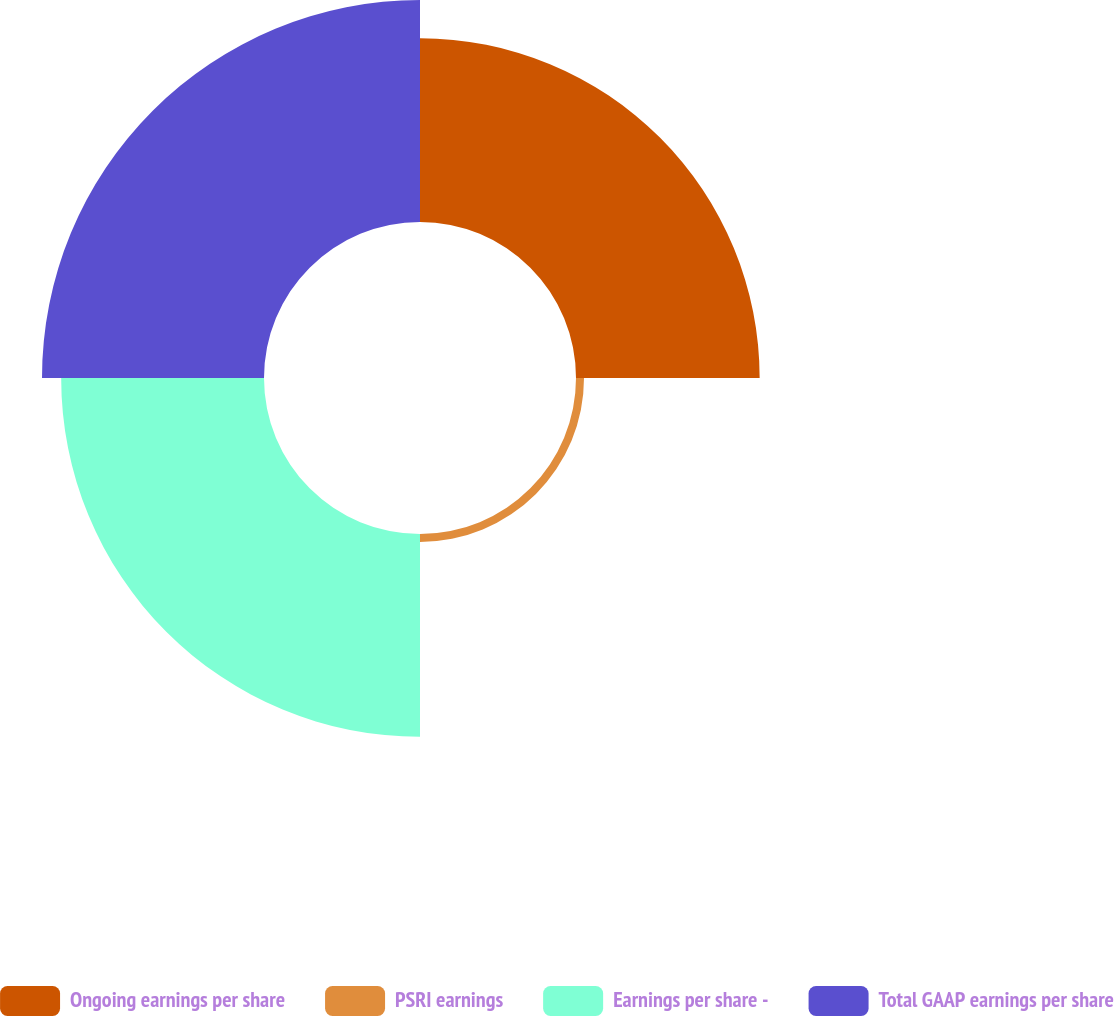Convert chart to OTSL. <chart><loc_0><loc_0><loc_500><loc_500><pie_chart><fcel>Ongoing earnings per share<fcel>PSRI earnings<fcel>Earnings per share -<fcel>Total GAAP earnings per share<nl><fcel>29.79%<fcel>1.3%<fcel>32.9%<fcel>36.01%<nl></chart> 